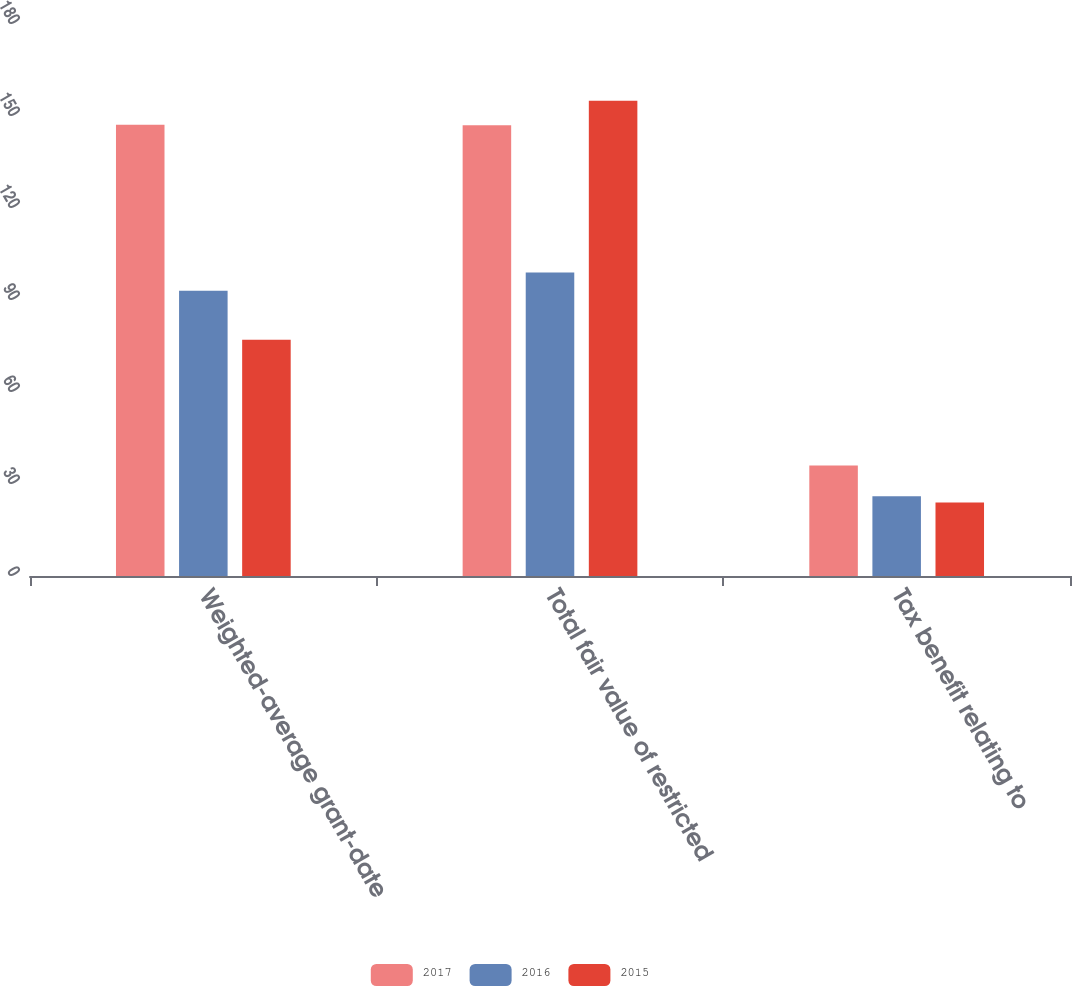Convert chart. <chart><loc_0><loc_0><loc_500><loc_500><stacked_bar_chart><ecel><fcel>Weighted-average grant-date<fcel>Total fair value of restricted<fcel>Tax benefit relating to<nl><fcel>2017<fcel>147.12<fcel>147<fcel>36<nl><fcel>2016<fcel>93.01<fcel>99<fcel>26<nl><fcel>2015<fcel>77.06<fcel>155<fcel>24<nl></chart> 